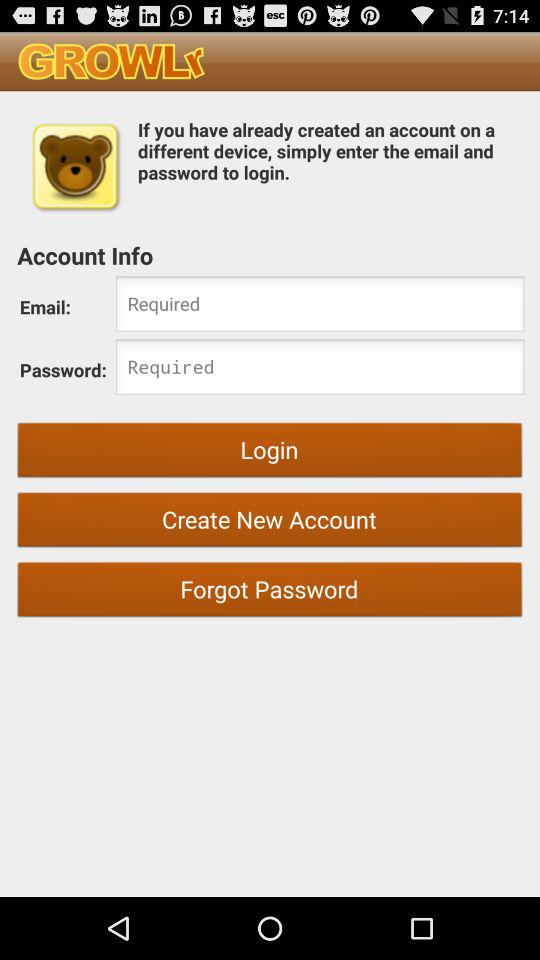What is the application name? The application name is "GROWLr". 